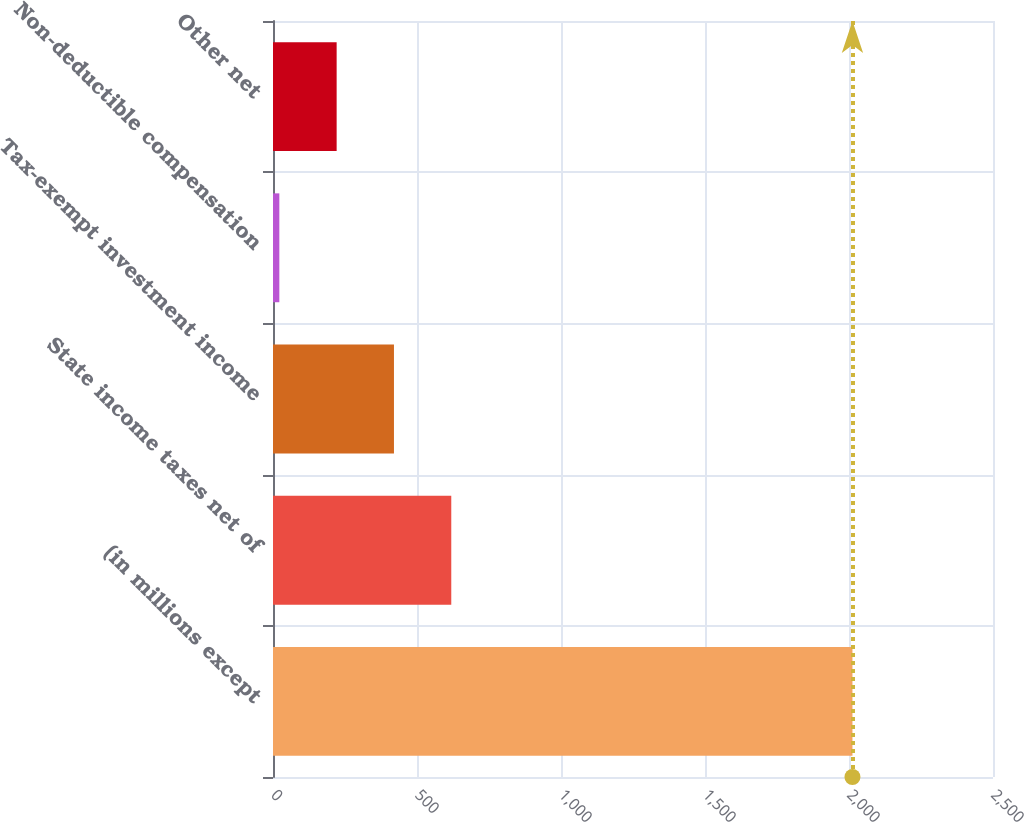Convert chart. <chart><loc_0><loc_0><loc_500><loc_500><bar_chart><fcel>(in millions except<fcel>State income taxes net of<fcel>Tax-exempt investment income<fcel>Non-deductible compensation<fcel>Other net<nl><fcel>2012<fcel>619<fcel>420<fcel>22<fcel>221<nl></chart> 